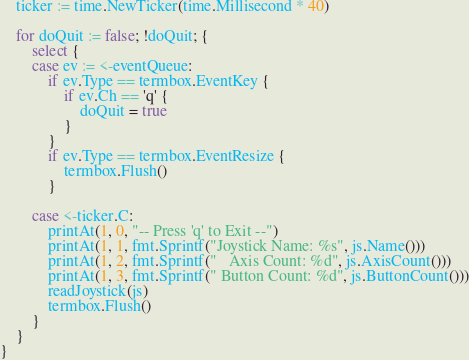Convert code to text. <code><loc_0><loc_0><loc_500><loc_500><_Go_>
	ticker := time.NewTicker(time.Millisecond * 40)

	for doQuit := false; !doQuit; {
		select {
		case ev := <-eventQueue:
			if ev.Type == termbox.EventKey {
				if ev.Ch == 'q' {
					doQuit = true
				}
			}
			if ev.Type == termbox.EventResize {
				termbox.Flush()
			}

		case <-ticker.C:
			printAt(1, 0, "-- Press 'q' to Exit --")
			printAt(1, 1, fmt.Sprintf("Joystick Name: %s", js.Name()))
			printAt(1, 2, fmt.Sprintf("   Axis Count: %d", js.AxisCount()))
			printAt(1, 3, fmt.Sprintf(" Button Count: %d", js.ButtonCount()))
			readJoystick(js)
			termbox.Flush()
		}
	}
}
</code> 